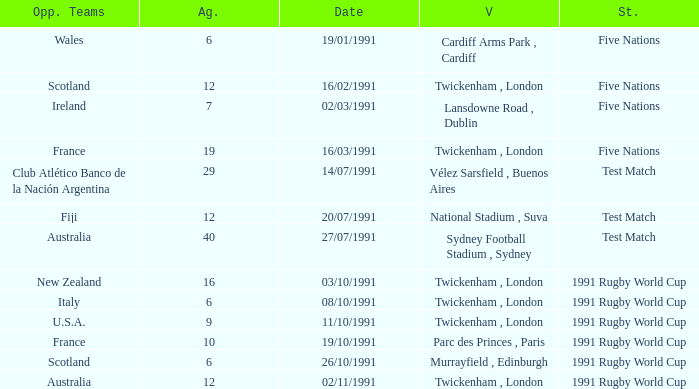What is Against, when Opposing Teams is "Australia", and when Date is "27/07/1991"? 40.0. Parse the full table. {'header': ['Opp. Teams', 'Ag.', 'Date', 'V', 'St.'], 'rows': [['Wales', '6', '19/01/1991', 'Cardiff Arms Park , Cardiff', 'Five Nations'], ['Scotland', '12', '16/02/1991', 'Twickenham , London', 'Five Nations'], ['Ireland', '7', '02/03/1991', 'Lansdowne Road , Dublin', 'Five Nations'], ['France', '19', '16/03/1991', 'Twickenham , London', 'Five Nations'], ['Club Atlético Banco de la Nación Argentina', '29', '14/07/1991', 'Vélez Sarsfield , Buenos Aires', 'Test Match'], ['Fiji', '12', '20/07/1991', 'National Stadium , Suva', 'Test Match'], ['Australia', '40', '27/07/1991', 'Sydney Football Stadium , Sydney', 'Test Match'], ['New Zealand', '16', '03/10/1991', 'Twickenham , London', '1991 Rugby World Cup'], ['Italy', '6', '08/10/1991', 'Twickenham , London', '1991 Rugby World Cup'], ['U.S.A.', '9', '11/10/1991', 'Twickenham , London', '1991 Rugby World Cup'], ['France', '10', '19/10/1991', 'Parc des Princes , Paris', '1991 Rugby World Cup'], ['Scotland', '6', '26/10/1991', 'Murrayfield , Edinburgh', '1991 Rugby World Cup'], ['Australia', '12', '02/11/1991', 'Twickenham , London', '1991 Rugby World Cup']]} 